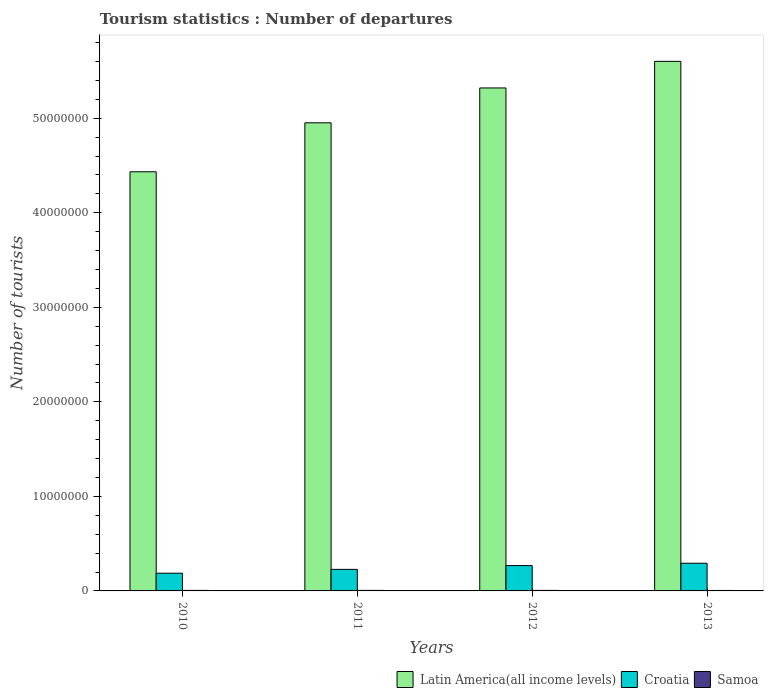How many different coloured bars are there?
Provide a short and direct response. 3. Are the number of bars per tick equal to the number of legend labels?
Offer a terse response. Yes. Are the number of bars on each tick of the X-axis equal?
Ensure brevity in your answer.  Yes. What is the label of the 1st group of bars from the left?
Your answer should be compact. 2010. What is the number of tourist departures in Samoa in 2013?
Ensure brevity in your answer.  5.10e+04. Across all years, what is the maximum number of tourist departures in Croatia?
Ensure brevity in your answer.  2.93e+06. Across all years, what is the minimum number of tourist departures in Latin America(all income levels)?
Provide a short and direct response. 4.43e+07. What is the total number of tourist departures in Latin America(all income levels) in the graph?
Keep it short and to the point. 2.03e+08. What is the difference between the number of tourist departures in Croatia in 2010 and that in 2013?
Your answer should be compact. -1.05e+06. What is the difference between the number of tourist departures in Croatia in 2010 and the number of tourist departures in Samoa in 2012?
Your answer should be very brief. 1.82e+06. What is the average number of tourist departures in Croatia per year?
Provide a short and direct response. 2.44e+06. In the year 2010, what is the difference between the number of tourist departures in Croatia and number of tourist departures in Samoa?
Your answer should be compact. 1.82e+06. In how many years, is the number of tourist departures in Samoa greater than 40000000?
Your answer should be very brief. 0. What is the ratio of the number of tourist departures in Latin America(all income levels) in 2010 to that in 2013?
Ensure brevity in your answer.  0.79. Is the number of tourist departures in Croatia in 2011 less than that in 2012?
Keep it short and to the point. Yes. Is the difference between the number of tourist departures in Croatia in 2010 and 2012 greater than the difference between the number of tourist departures in Samoa in 2010 and 2012?
Your response must be concise. No. What is the difference between the highest and the lowest number of tourist departures in Samoa?
Offer a very short reply. 6000. In how many years, is the number of tourist departures in Samoa greater than the average number of tourist departures in Samoa taken over all years?
Offer a very short reply. 3. What does the 3rd bar from the left in 2010 represents?
Your answer should be very brief. Samoa. What does the 2nd bar from the right in 2010 represents?
Offer a very short reply. Croatia. How many years are there in the graph?
Your answer should be very brief. 4. What is the difference between two consecutive major ticks on the Y-axis?
Your answer should be very brief. 1.00e+07. Are the values on the major ticks of Y-axis written in scientific E-notation?
Make the answer very short. No. Does the graph contain any zero values?
Ensure brevity in your answer.  No. How are the legend labels stacked?
Your response must be concise. Horizontal. What is the title of the graph?
Offer a terse response. Tourism statistics : Number of departures. What is the label or title of the Y-axis?
Ensure brevity in your answer.  Number of tourists. What is the Number of tourists in Latin America(all income levels) in 2010?
Provide a short and direct response. 4.43e+07. What is the Number of tourists in Croatia in 2010?
Give a very brief answer. 1.87e+06. What is the Number of tourists in Samoa in 2010?
Ensure brevity in your answer.  5.60e+04. What is the Number of tourists of Latin America(all income levels) in 2011?
Provide a short and direct response. 4.95e+07. What is the Number of tourists of Croatia in 2011?
Your response must be concise. 2.28e+06. What is the Number of tourists in Samoa in 2011?
Offer a very short reply. 5.70e+04. What is the Number of tourists of Latin America(all income levels) in 2012?
Provide a short and direct response. 5.32e+07. What is the Number of tourists of Croatia in 2012?
Make the answer very short. 2.68e+06. What is the Number of tourists of Samoa in 2012?
Give a very brief answer. 5.60e+04. What is the Number of tourists in Latin America(all income levels) in 2013?
Your answer should be very brief. 5.60e+07. What is the Number of tourists in Croatia in 2013?
Offer a terse response. 2.93e+06. What is the Number of tourists of Samoa in 2013?
Offer a very short reply. 5.10e+04. Across all years, what is the maximum Number of tourists in Latin America(all income levels)?
Provide a short and direct response. 5.60e+07. Across all years, what is the maximum Number of tourists in Croatia?
Give a very brief answer. 2.93e+06. Across all years, what is the maximum Number of tourists in Samoa?
Offer a terse response. 5.70e+04. Across all years, what is the minimum Number of tourists in Latin America(all income levels)?
Provide a succinct answer. 4.43e+07. Across all years, what is the minimum Number of tourists in Croatia?
Keep it short and to the point. 1.87e+06. Across all years, what is the minimum Number of tourists of Samoa?
Make the answer very short. 5.10e+04. What is the total Number of tourists of Latin America(all income levels) in the graph?
Provide a succinct answer. 2.03e+08. What is the total Number of tourists in Croatia in the graph?
Make the answer very short. 9.76e+06. What is the difference between the Number of tourists in Latin America(all income levels) in 2010 and that in 2011?
Your answer should be compact. -5.18e+06. What is the difference between the Number of tourists in Croatia in 2010 and that in 2011?
Provide a succinct answer. -4.07e+05. What is the difference between the Number of tourists in Samoa in 2010 and that in 2011?
Offer a very short reply. -1000. What is the difference between the Number of tourists of Latin America(all income levels) in 2010 and that in 2012?
Offer a terse response. -8.87e+06. What is the difference between the Number of tourists in Croatia in 2010 and that in 2012?
Your answer should be compact. -8.07e+05. What is the difference between the Number of tourists of Latin America(all income levels) in 2010 and that in 2013?
Provide a short and direct response. -1.17e+07. What is the difference between the Number of tourists of Croatia in 2010 and that in 2013?
Your response must be concise. -1.05e+06. What is the difference between the Number of tourists in Latin America(all income levels) in 2011 and that in 2012?
Make the answer very short. -3.69e+06. What is the difference between the Number of tourists in Croatia in 2011 and that in 2012?
Ensure brevity in your answer.  -4.00e+05. What is the difference between the Number of tourists of Latin America(all income levels) in 2011 and that in 2013?
Your answer should be very brief. -6.50e+06. What is the difference between the Number of tourists in Croatia in 2011 and that in 2013?
Offer a terse response. -6.47e+05. What is the difference between the Number of tourists in Samoa in 2011 and that in 2013?
Keep it short and to the point. 6000. What is the difference between the Number of tourists of Latin America(all income levels) in 2012 and that in 2013?
Your response must be concise. -2.81e+06. What is the difference between the Number of tourists of Croatia in 2012 and that in 2013?
Ensure brevity in your answer.  -2.47e+05. What is the difference between the Number of tourists of Latin America(all income levels) in 2010 and the Number of tourists of Croatia in 2011?
Your response must be concise. 4.21e+07. What is the difference between the Number of tourists of Latin America(all income levels) in 2010 and the Number of tourists of Samoa in 2011?
Make the answer very short. 4.43e+07. What is the difference between the Number of tourists in Croatia in 2010 and the Number of tourists in Samoa in 2011?
Provide a short and direct response. 1.82e+06. What is the difference between the Number of tourists of Latin America(all income levels) in 2010 and the Number of tourists of Croatia in 2012?
Your answer should be compact. 4.17e+07. What is the difference between the Number of tourists of Latin America(all income levels) in 2010 and the Number of tourists of Samoa in 2012?
Ensure brevity in your answer.  4.43e+07. What is the difference between the Number of tourists in Croatia in 2010 and the Number of tourists in Samoa in 2012?
Ensure brevity in your answer.  1.82e+06. What is the difference between the Number of tourists in Latin America(all income levels) in 2010 and the Number of tourists in Croatia in 2013?
Ensure brevity in your answer.  4.14e+07. What is the difference between the Number of tourists of Latin America(all income levels) in 2010 and the Number of tourists of Samoa in 2013?
Provide a succinct answer. 4.43e+07. What is the difference between the Number of tourists of Croatia in 2010 and the Number of tourists of Samoa in 2013?
Give a very brief answer. 1.82e+06. What is the difference between the Number of tourists of Latin America(all income levels) in 2011 and the Number of tourists of Croatia in 2012?
Offer a terse response. 4.68e+07. What is the difference between the Number of tourists in Latin America(all income levels) in 2011 and the Number of tourists in Samoa in 2012?
Ensure brevity in your answer.  4.95e+07. What is the difference between the Number of tourists of Croatia in 2011 and the Number of tourists of Samoa in 2012?
Offer a very short reply. 2.22e+06. What is the difference between the Number of tourists of Latin America(all income levels) in 2011 and the Number of tourists of Croatia in 2013?
Your answer should be very brief. 4.66e+07. What is the difference between the Number of tourists in Latin America(all income levels) in 2011 and the Number of tourists in Samoa in 2013?
Ensure brevity in your answer.  4.95e+07. What is the difference between the Number of tourists in Croatia in 2011 and the Number of tourists in Samoa in 2013?
Keep it short and to the point. 2.23e+06. What is the difference between the Number of tourists in Latin America(all income levels) in 2012 and the Number of tourists in Croatia in 2013?
Provide a succinct answer. 5.03e+07. What is the difference between the Number of tourists of Latin America(all income levels) in 2012 and the Number of tourists of Samoa in 2013?
Your answer should be compact. 5.32e+07. What is the difference between the Number of tourists in Croatia in 2012 and the Number of tourists in Samoa in 2013?
Ensure brevity in your answer.  2.63e+06. What is the average Number of tourists of Latin America(all income levels) per year?
Make the answer very short. 5.08e+07. What is the average Number of tourists in Croatia per year?
Your answer should be compact. 2.44e+06. What is the average Number of tourists in Samoa per year?
Provide a succinct answer. 5.50e+04. In the year 2010, what is the difference between the Number of tourists in Latin America(all income levels) and Number of tourists in Croatia?
Provide a short and direct response. 4.25e+07. In the year 2010, what is the difference between the Number of tourists of Latin America(all income levels) and Number of tourists of Samoa?
Make the answer very short. 4.43e+07. In the year 2010, what is the difference between the Number of tourists of Croatia and Number of tourists of Samoa?
Keep it short and to the point. 1.82e+06. In the year 2011, what is the difference between the Number of tourists in Latin America(all income levels) and Number of tourists in Croatia?
Make the answer very short. 4.72e+07. In the year 2011, what is the difference between the Number of tourists of Latin America(all income levels) and Number of tourists of Samoa?
Your response must be concise. 4.95e+07. In the year 2011, what is the difference between the Number of tourists in Croatia and Number of tourists in Samoa?
Ensure brevity in your answer.  2.22e+06. In the year 2012, what is the difference between the Number of tourists in Latin America(all income levels) and Number of tourists in Croatia?
Give a very brief answer. 5.05e+07. In the year 2012, what is the difference between the Number of tourists in Latin America(all income levels) and Number of tourists in Samoa?
Provide a short and direct response. 5.31e+07. In the year 2012, what is the difference between the Number of tourists of Croatia and Number of tourists of Samoa?
Offer a very short reply. 2.62e+06. In the year 2013, what is the difference between the Number of tourists in Latin America(all income levels) and Number of tourists in Croatia?
Offer a very short reply. 5.31e+07. In the year 2013, what is the difference between the Number of tourists in Latin America(all income levels) and Number of tourists in Samoa?
Ensure brevity in your answer.  5.60e+07. In the year 2013, what is the difference between the Number of tourists of Croatia and Number of tourists of Samoa?
Your answer should be very brief. 2.88e+06. What is the ratio of the Number of tourists of Latin America(all income levels) in 2010 to that in 2011?
Your answer should be very brief. 0.9. What is the ratio of the Number of tourists of Croatia in 2010 to that in 2011?
Make the answer very short. 0.82. What is the ratio of the Number of tourists of Samoa in 2010 to that in 2011?
Keep it short and to the point. 0.98. What is the ratio of the Number of tourists in Croatia in 2010 to that in 2012?
Your response must be concise. 0.7. What is the ratio of the Number of tourists in Latin America(all income levels) in 2010 to that in 2013?
Give a very brief answer. 0.79. What is the ratio of the Number of tourists of Croatia in 2010 to that in 2013?
Give a very brief answer. 0.64. What is the ratio of the Number of tourists in Samoa in 2010 to that in 2013?
Ensure brevity in your answer.  1.1. What is the ratio of the Number of tourists in Latin America(all income levels) in 2011 to that in 2012?
Your response must be concise. 0.93. What is the ratio of the Number of tourists in Croatia in 2011 to that in 2012?
Offer a terse response. 0.85. What is the ratio of the Number of tourists of Samoa in 2011 to that in 2012?
Make the answer very short. 1.02. What is the ratio of the Number of tourists in Latin America(all income levels) in 2011 to that in 2013?
Your response must be concise. 0.88. What is the ratio of the Number of tourists of Croatia in 2011 to that in 2013?
Your answer should be very brief. 0.78. What is the ratio of the Number of tourists in Samoa in 2011 to that in 2013?
Give a very brief answer. 1.12. What is the ratio of the Number of tourists of Latin America(all income levels) in 2012 to that in 2013?
Give a very brief answer. 0.95. What is the ratio of the Number of tourists of Croatia in 2012 to that in 2013?
Provide a succinct answer. 0.92. What is the ratio of the Number of tourists in Samoa in 2012 to that in 2013?
Your answer should be very brief. 1.1. What is the difference between the highest and the second highest Number of tourists of Latin America(all income levels)?
Offer a terse response. 2.81e+06. What is the difference between the highest and the second highest Number of tourists of Croatia?
Give a very brief answer. 2.47e+05. What is the difference between the highest and the second highest Number of tourists in Samoa?
Keep it short and to the point. 1000. What is the difference between the highest and the lowest Number of tourists in Latin America(all income levels)?
Keep it short and to the point. 1.17e+07. What is the difference between the highest and the lowest Number of tourists in Croatia?
Offer a very short reply. 1.05e+06. What is the difference between the highest and the lowest Number of tourists in Samoa?
Ensure brevity in your answer.  6000. 